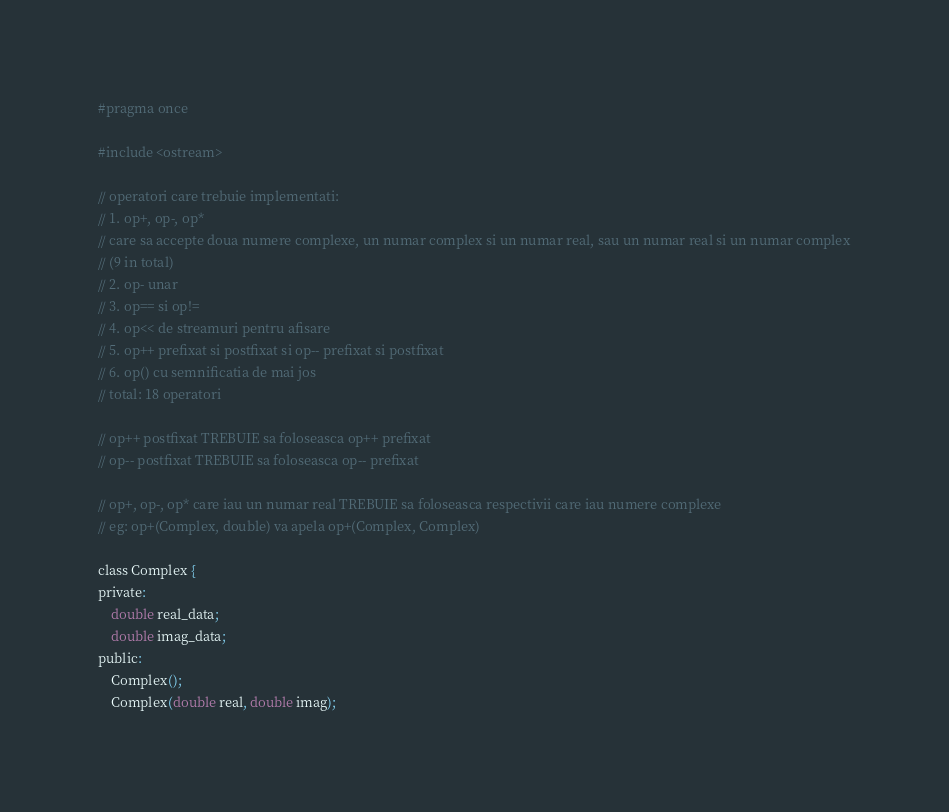<code> <loc_0><loc_0><loc_500><loc_500><_C_>#pragma once

#include <ostream>

// operatori care trebuie implementati:
// 1. op+, op-, op*
// care sa accepte doua numere complexe, un numar complex si un numar real, sau un numar real si un numar complex
// (9 in total)
// 2. op- unar
// 3. op== si op!=
// 4. op<< de streamuri pentru afisare
// 5. op++ prefixat si postfixat si op-- prefixat si postfixat
// 6. op() cu semnificatia de mai jos
// total: 18 operatori

// op++ postfixat TREBUIE sa foloseasca op++ prefixat
// op-- postfixat TREBUIE sa foloseasca op-- prefixat

// op+, op-, op* care iau un numar real TREBUIE sa foloseasca respectivii care iau numere complexe
// eg: op+(Complex, double) va apela op+(Complex, Complex)

class Complex {
private:
    double real_data;
    double imag_data;
public:
    Complex();
    Complex(double real, double imag);
</code> 